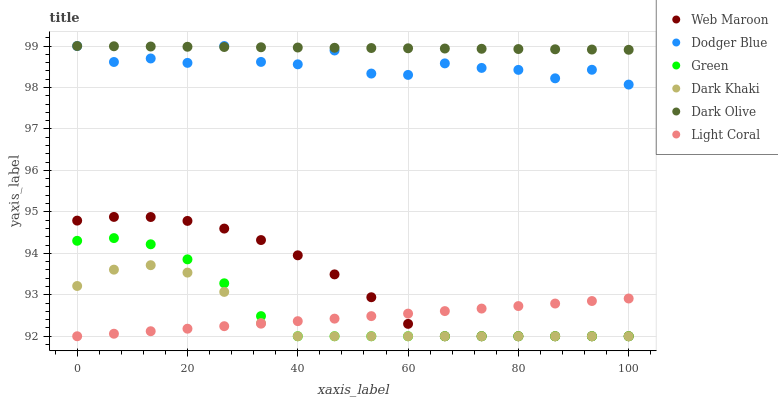Does Light Coral have the minimum area under the curve?
Answer yes or no. Yes. Does Dark Olive have the maximum area under the curve?
Answer yes or no. Yes. Does Web Maroon have the minimum area under the curve?
Answer yes or no. No. Does Web Maroon have the maximum area under the curve?
Answer yes or no. No. Is Light Coral the smoothest?
Answer yes or no. Yes. Is Dodger Blue the roughest?
Answer yes or no. Yes. Is Dark Olive the smoothest?
Answer yes or no. No. Is Dark Olive the roughest?
Answer yes or no. No. Does Light Coral have the lowest value?
Answer yes or no. Yes. Does Dark Olive have the lowest value?
Answer yes or no. No. Does Dodger Blue have the highest value?
Answer yes or no. Yes. Does Web Maroon have the highest value?
Answer yes or no. No. Is Green less than Dodger Blue?
Answer yes or no. Yes. Is Dark Olive greater than Light Coral?
Answer yes or no. Yes. Does Web Maroon intersect Green?
Answer yes or no. Yes. Is Web Maroon less than Green?
Answer yes or no. No. Is Web Maroon greater than Green?
Answer yes or no. No. Does Green intersect Dodger Blue?
Answer yes or no. No. 